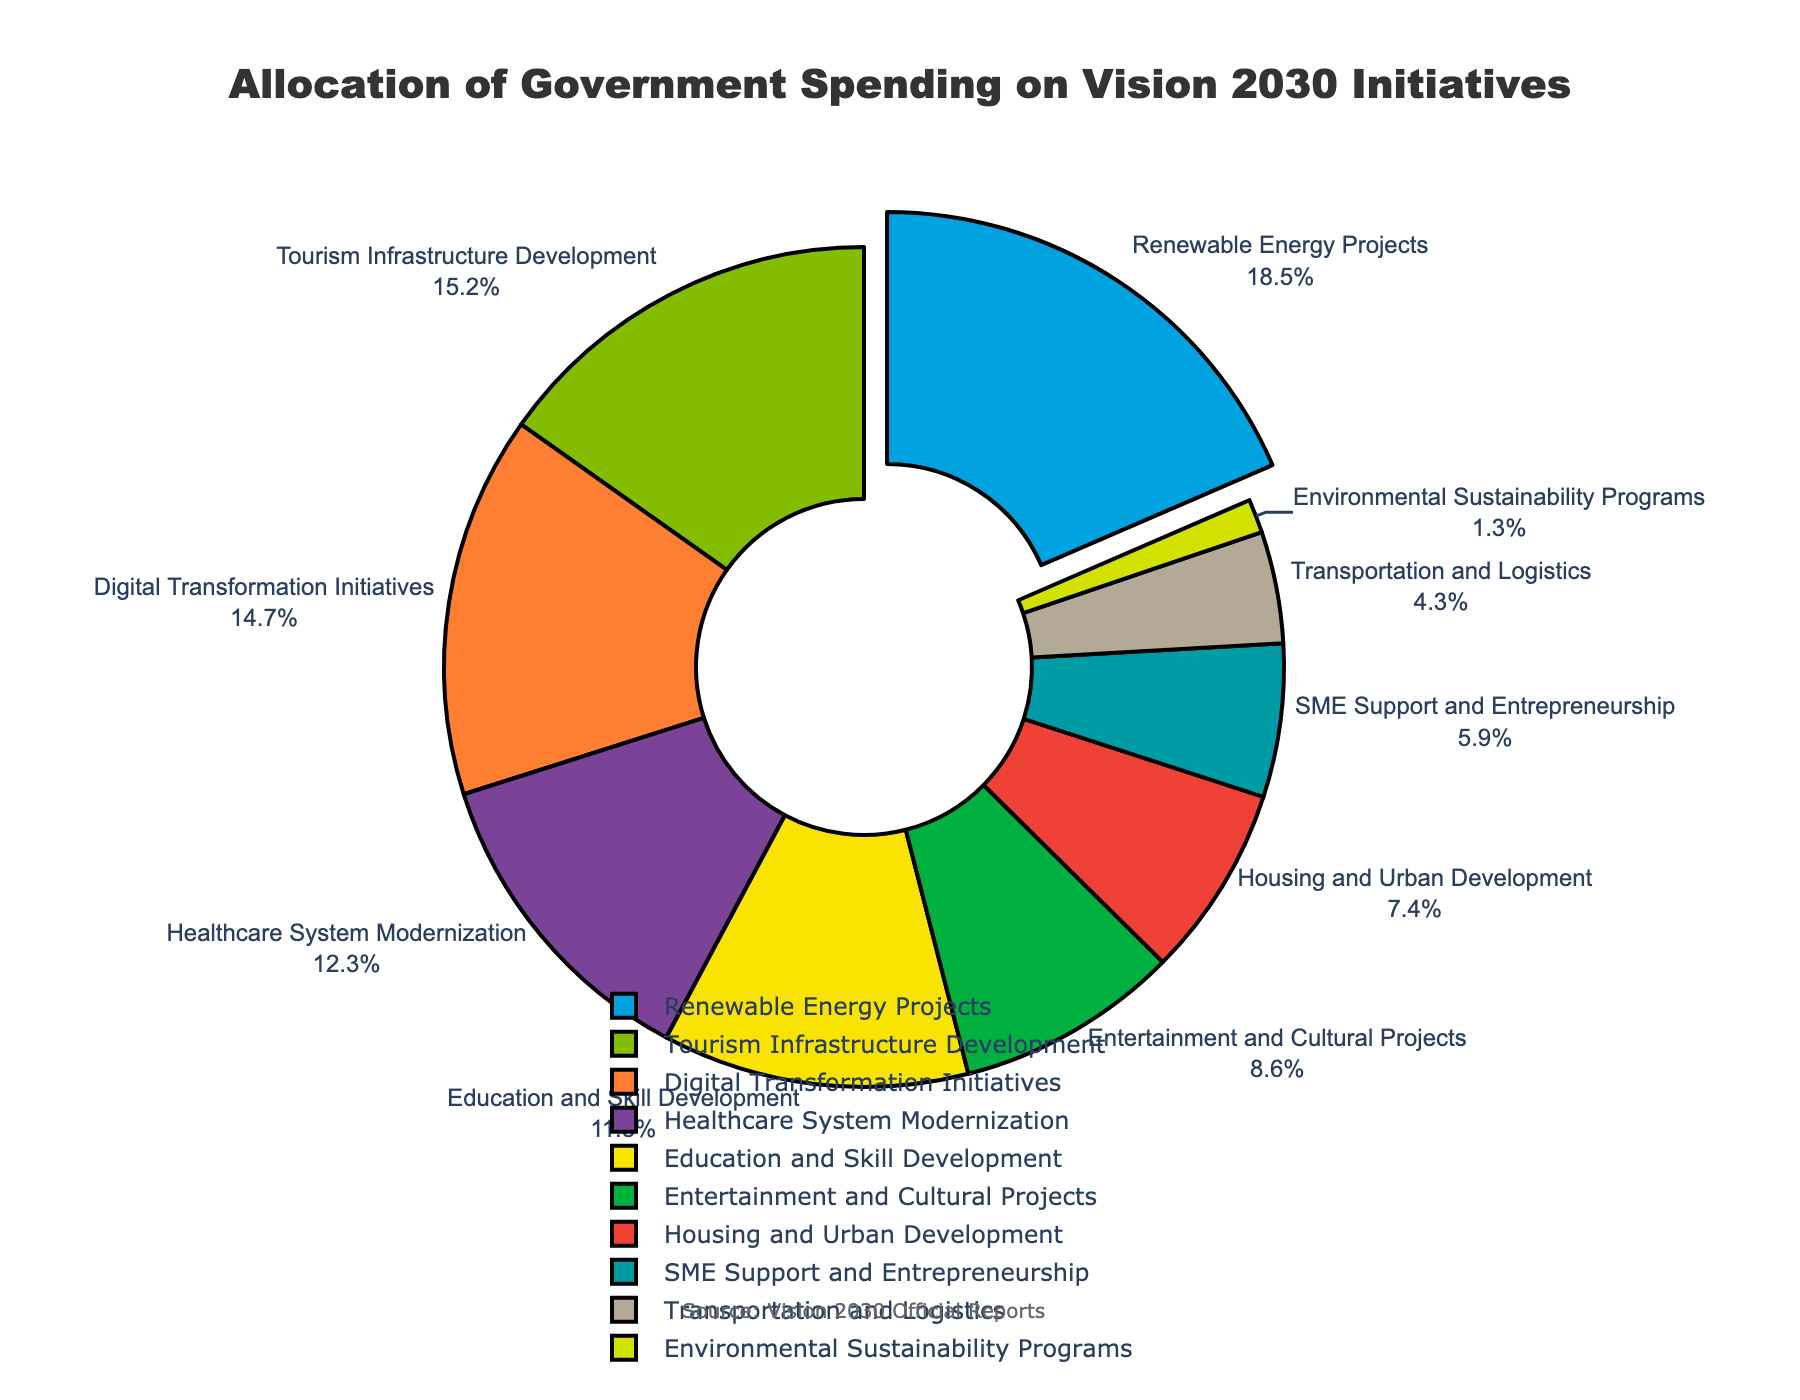What percentage of the budget is allocated to Healthcare System Modernization? To find the allocation percentage for Healthcare System Modernization, look for the segment labeled "Healthcare System Modernization" in the pie chart, which shows 12.3%
Answer: 12.3% Which sector receives more funding, Tourism Infrastructure Development or Digital Transformation Initiatives? Compare the percentages of the two sectors. Tourism Infrastructure Development receives 15.2%, while Digital Transformation Initiatives receives 14.7%. Thus, Tourism Infrastructure Development receives more funding.
Answer: Tourism Infrastructure Development What is the combined allocation for Education and Skill Development and Entertainment and Cultural Projects? Add the percentages of Education and Skill Development (11.8%) and Entertainment and Cultural Projects (8.6%): 11.8 + 8.6 = 20.4
Answer: 20.4 Which sector has the smallest allocation? Identify the sector with the smallest percentage in the pie chart. Environmental Sustainability Programs have the smallest allocation at 1.3%.
Answer: Environmental Sustainability Programs How much more funding is allocated to Housing and Urban Development compared to Transportation and Logistics? Subtract the percentage of Transportation and Logistics (4.3%) from Housing and Urban Development (7.4%): 7.4 - 4.3 = 3.1
Answer: 3.1 What percentage of the total budget is allocated to sectors related to Renewable Energy Projects and Tourism Infrastructure Development combined? Add the percentages of Renewable Energy Projects (18.5%) and Tourism Infrastructure Development (15.2%): 18.5 + 15.2 = 33.7
Answer: 33.7 Which sector is represented by the green segment in the pie chart? Identify the color associated with the segment in the pie chart. The green segment represents Tourism Infrastructure Development.
Answer: Tourism Infrastructure Development If the total budget were $100 billion, how much money would be spent on SME Support and Entrepreneurship? Calculate 5.9% of $100 billion. Convert the percentage to decimal (0.059) and multiply by 100 billion: 0.059 * 100,000,000,000 = $5.9 billion
Answer: $5.9 billion What is the difference in allocation between the sector with the highest percentage and the sector with the lowest percentage? Identify the highest percentage (Renewable Energy Projects at 18.5%) and the lowest percentage (Environmental Sustainability Programs at 1.3%) and subtract the latter from the former: 18.5 - 1.3 = 17.2
Answer: 17.2 